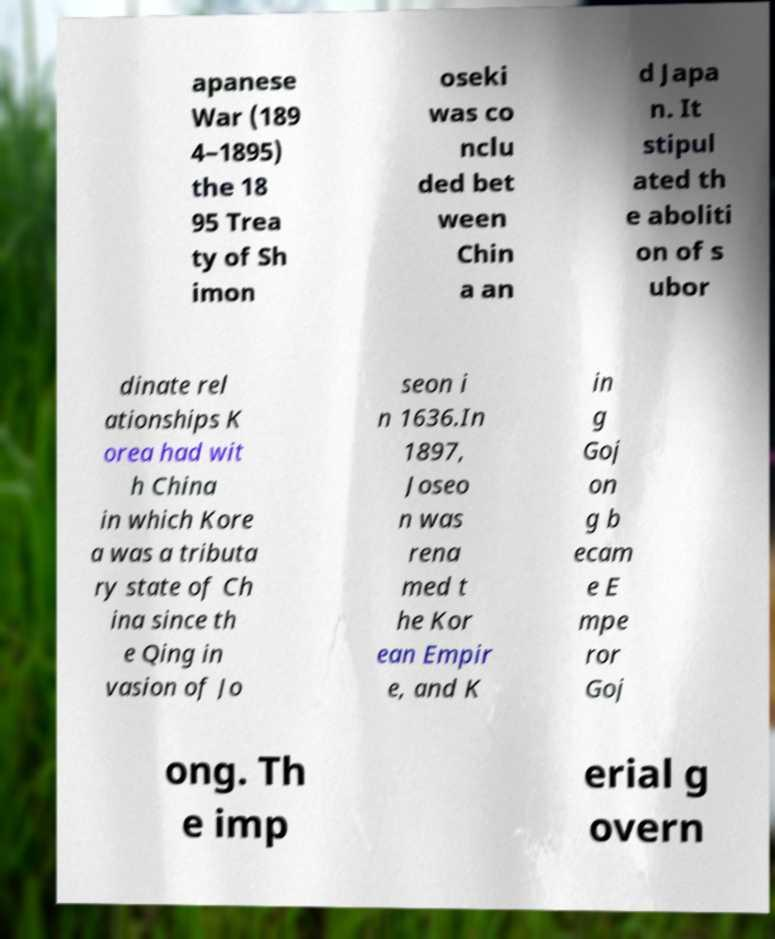What messages or text are displayed in this image? I need them in a readable, typed format. apanese War (189 4–1895) the 18 95 Trea ty of Sh imon oseki was co nclu ded bet ween Chin a an d Japa n. It stipul ated th e aboliti on of s ubor dinate rel ationships K orea had wit h China in which Kore a was a tributa ry state of Ch ina since th e Qing in vasion of Jo seon i n 1636.In 1897, Joseo n was rena med t he Kor ean Empir e, and K in g Goj on g b ecam e E mpe ror Goj ong. Th e imp erial g overn 